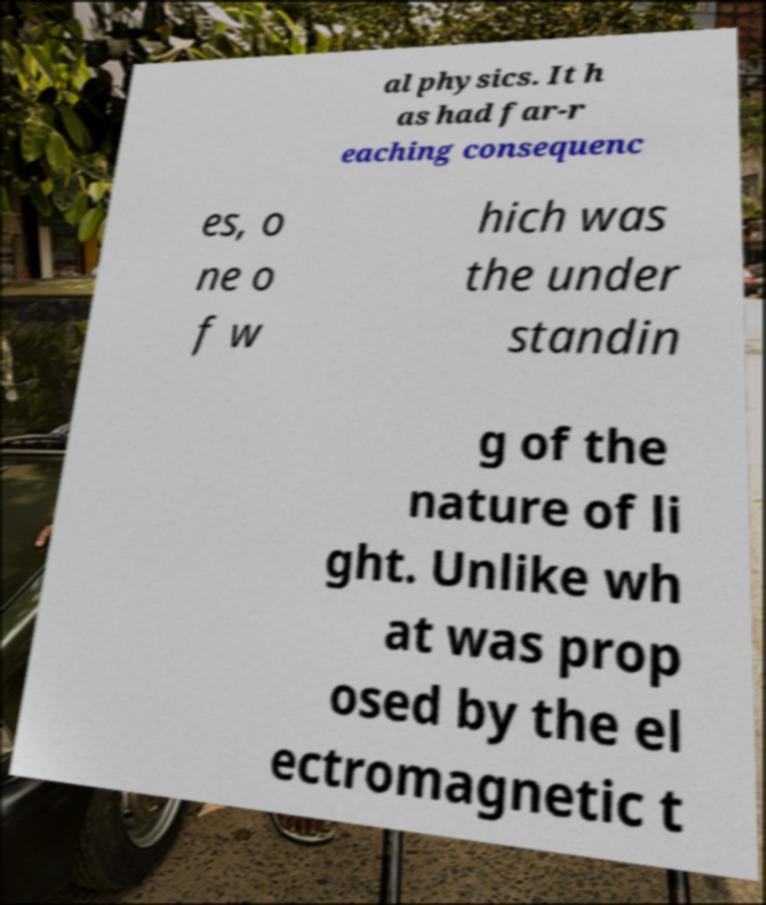Could you assist in decoding the text presented in this image and type it out clearly? al physics. It h as had far-r eaching consequenc es, o ne o f w hich was the under standin g of the nature of li ght. Unlike wh at was prop osed by the el ectromagnetic t 